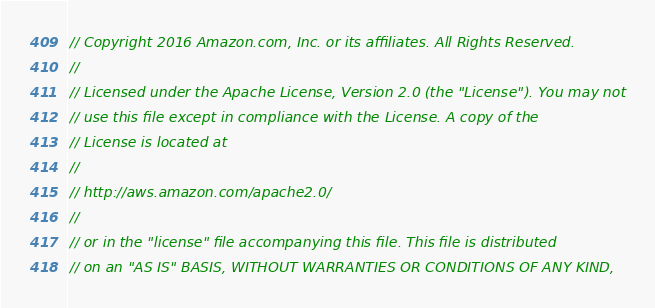Convert code to text. <code><loc_0><loc_0><loc_500><loc_500><_Go_>// Copyright 2016 Amazon.com, Inc. or its affiliates. All Rights Reserved.
//
// Licensed under the Apache License, Version 2.0 (the "License"). You may not
// use this file except in compliance with the License. A copy of the
// License is located at
//
// http://aws.amazon.com/apache2.0/
//
// or in the "license" file accompanying this file. This file is distributed
// on an "AS IS" BASIS, WITHOUT WARRANTIES OR CONDITIONS OF ANY KIND,</code> 